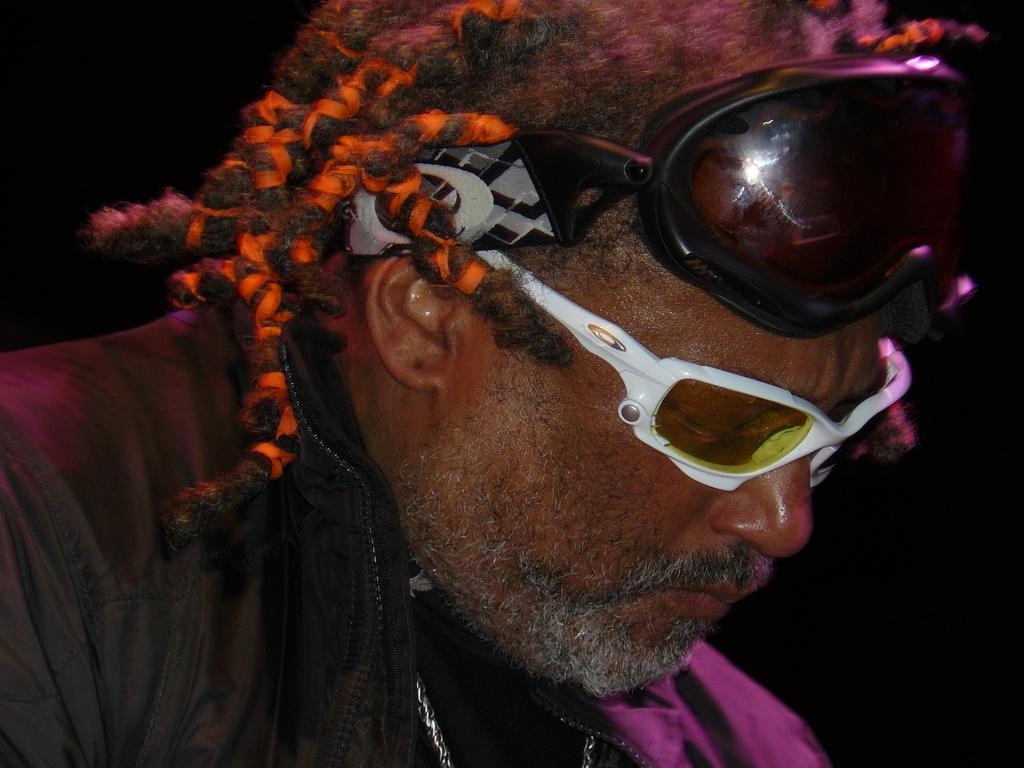Could you give a brief overview of what you see in this image? In this image I can see a man in the front and I can see he is wearing a black colour jacket. I can also see a goggles on his head and I can see he is wearing a white colour shades. 